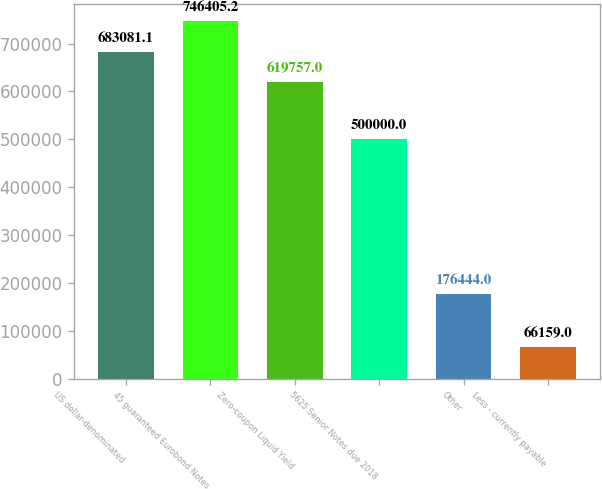Convert chart to OTSL. <chart><loc_0><loc_0><loc_500><loc_500><bar_chart><fcel>US dollar-denominated<fcel>45 guaranteed Eurobond Notes<fcel>Zero-coupon Liquid Yield<fcel>5625 Senior Notes due 2018<fcel>Other<fcel>Less - currently payable<nl><fcel>683081<fcel>746405<fcel>619757<fcel>500000<fcel>176444<fcel>66159<nl></chart> 